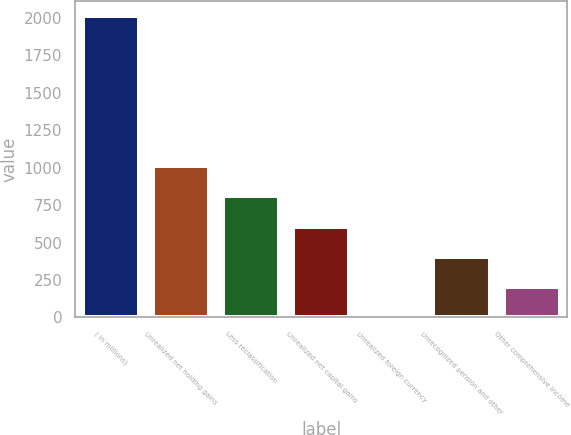<chart> <loc_0><loc_0><loc_500><loc_500><bar_chart><fcel>( in millions)<fcel>Unrealized net holding gains<fcel>Less reclassification<fcel>Unrealized net capital gains<fcel>Unrealized foreign currency<fcel>Unrecognized pension and other<fcel>Other comprehensive income<nl><fcel>2011<fcel>1008.5<fcel>808<fcel>607.5<fcel>6<fcel>407<fcel>206.5<nl></chart> 